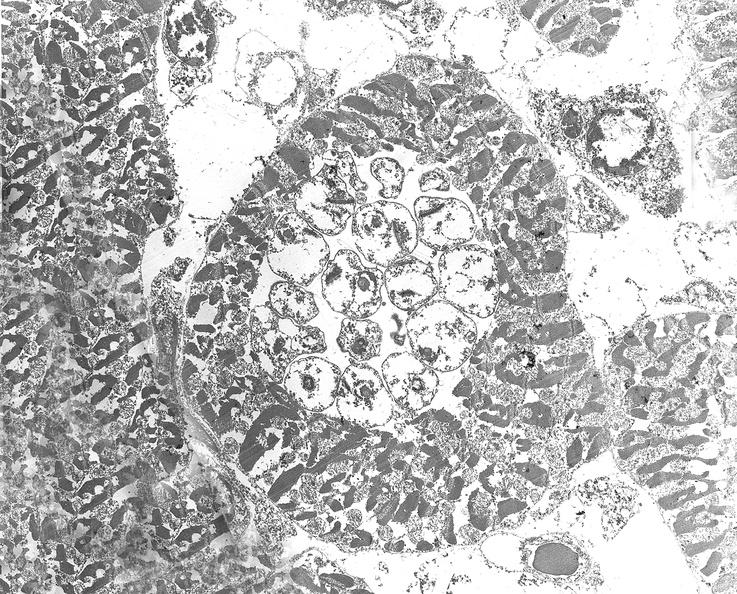does amyloidosis show chagas disease, acute, trypanasoma cruzi?
Answer the question using a single word or phrase. No 